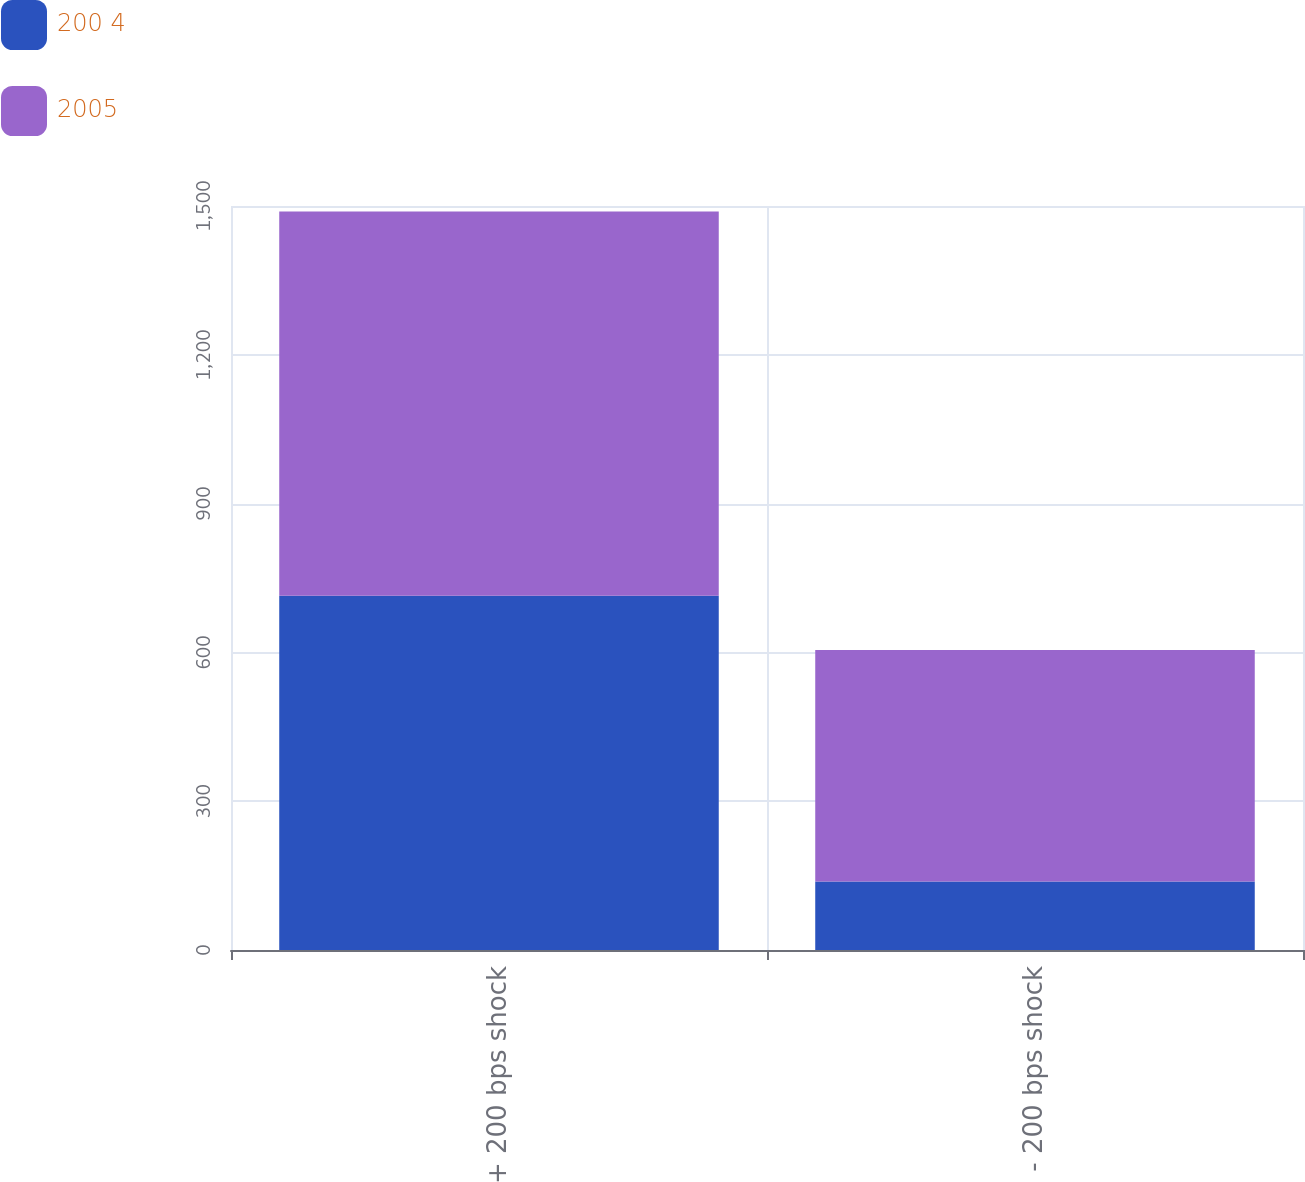<chart> <loc_0><loc_0><loc_500><loc_500><stacked_bar_chart><ecel><fcel>+ 200 bps shock<fcel>- 200 bps shock<nl><fcel>200 4<fcel>714<fcel>138<nl><fcel>2005<fcel>775<fcel>467<nl></chart> 